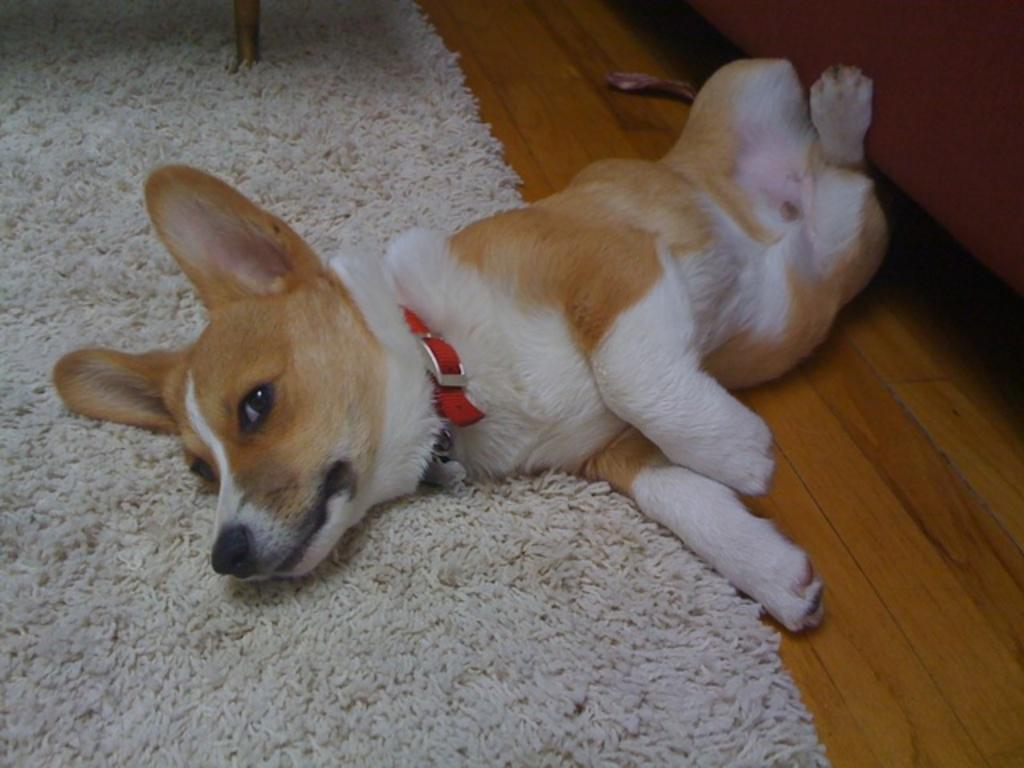What type of animal is in the picture? There is a dog in the picture. What is the dog doing in the picture? The dog is laying on a surface. What part of the dog's body is on the carpet? Half of the dog's body is on a carpet. Where is the crowd gathered around the lake in the image? There is no crowd or lake present in the image; it only features a dog laying on a surface. 